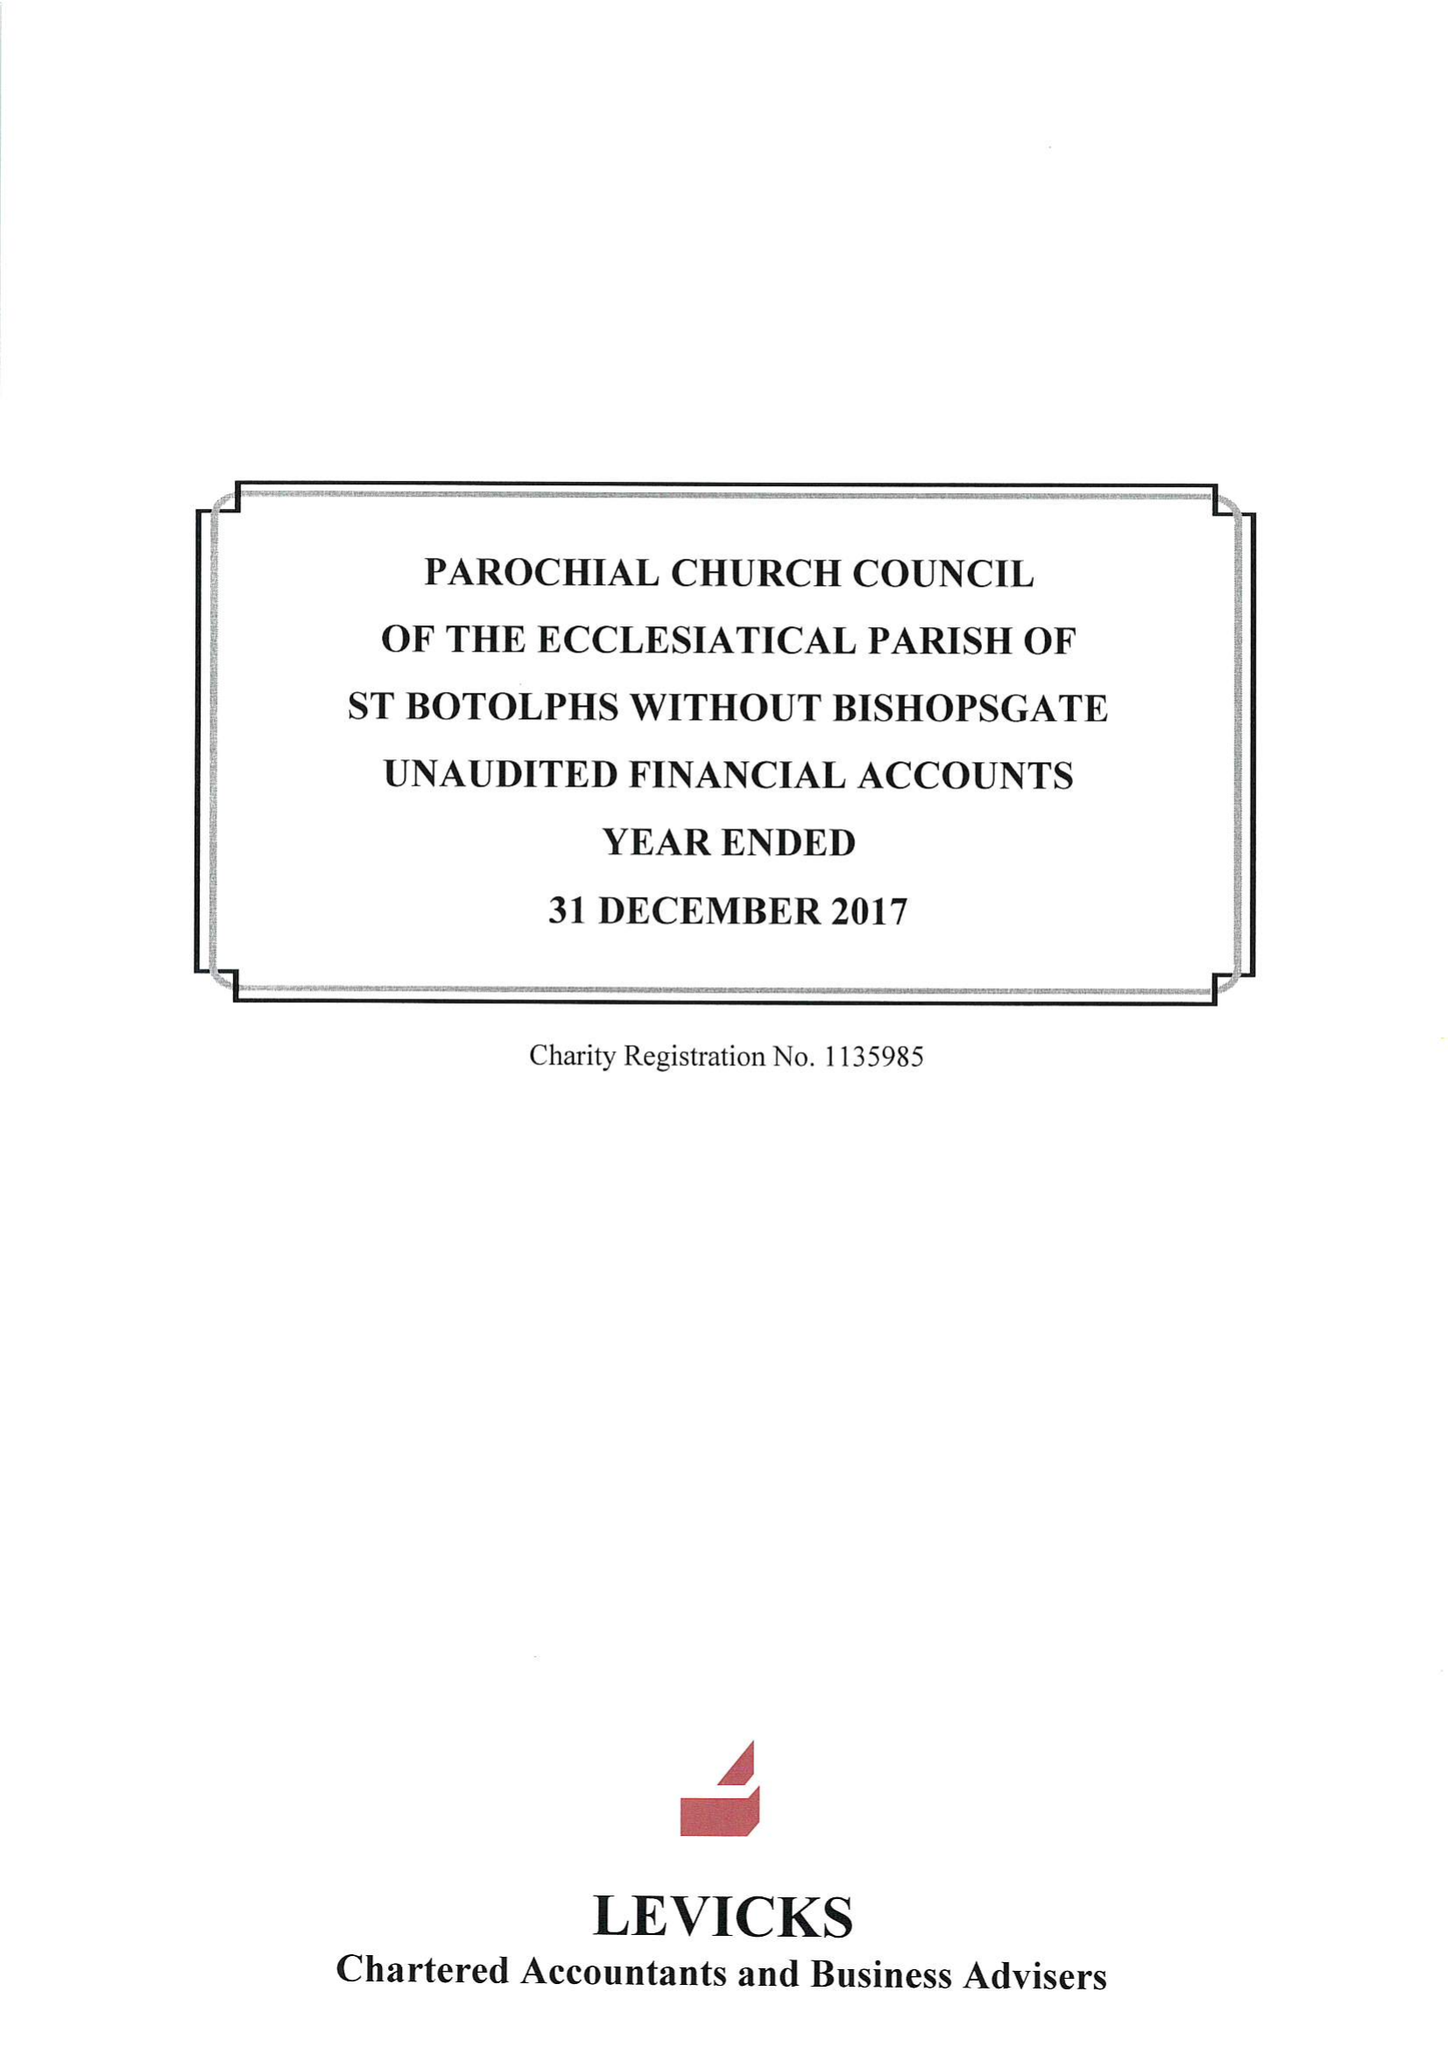What is the value for the address__postcode?
Answer the question using a single word or phrase. EC2M 3TL 